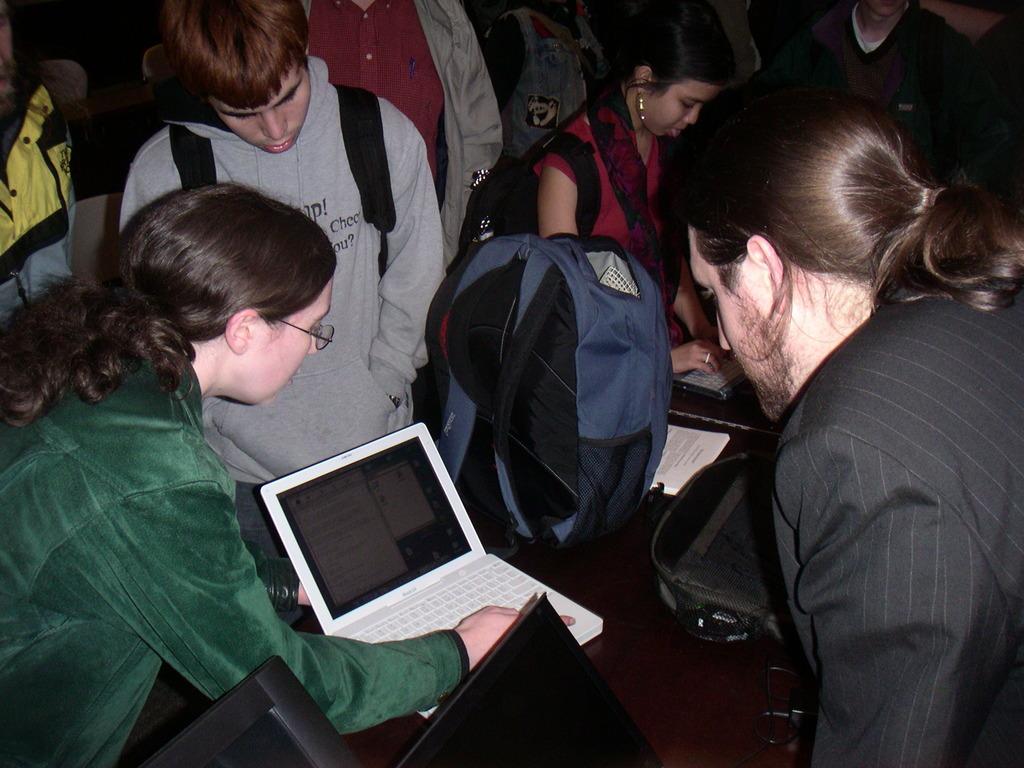How would you summarize this image in a sentence or two? As we can see in the image there are few people, a laptop and a bag. 